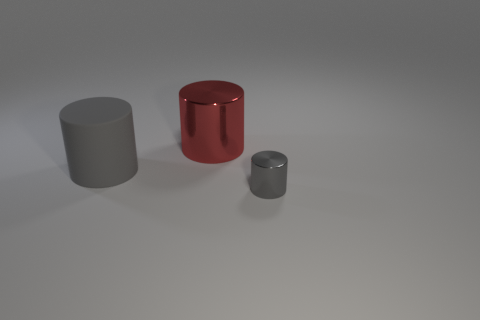Are there any red objects in front of the gray cylinder that is behind the small shiny cylinder?
Provide a succinct answer. No. How many other things are the same color as the matte thing?
Provide a succinct answer. 1. There is a gray cylinder to the right of the big gray matte cylinder; is it the same size as the metallic object behind the large gray cylinder?
Ensure brevity in your answer.  No. There is a metal object that is in front of the large object that is to the right of the large rubber thing; what is its size?
Make the answer very short. Small. What is the object that is in front of the big red metallic thing and to the right of the matte cylinder made of?
Provide a short and direct response. Metal. What color is the large metal cylinder?
Provide a succinct answer. Red. Is there anything else that is the same material as the large red cylinder?
Ensure brevity in your answer.  Yes. What is the shape of the metal object that is to the right of the red object?
Your answer should be compact. Cylinder. There is a gray thing on the right side of the gray object that is behind the gray metallic cylinder; are there any tiny gray shiny things left of it?
Your response must be concise. No. Are there any other things that have the same shape as the large red thing?
Your answer should be very brief. Yes. 